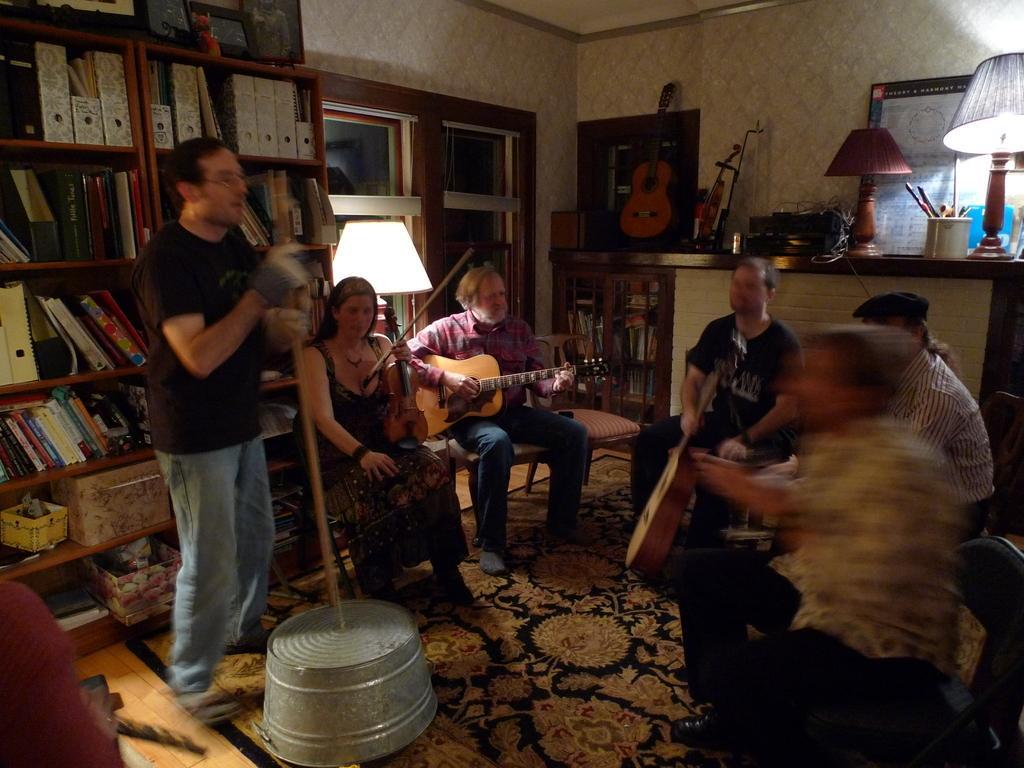How would you summarize this image in a sentence or two? This consist of six people performing music. It is clicked inside the room. To the left, there is a rack in which there are books. To the right, there is a desk on which lamps and frames are kept. At the bottom, there is a floor mat on the floor. In the middle, the man is playing guitar. 